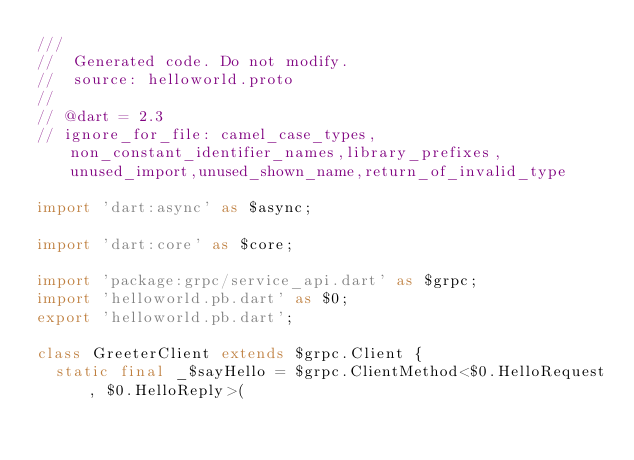Convert code to text. <code><loc_0><loc_0><loc_500><loc_500><_Dart_>///
//  Generated code. Do not modify.
//  source: helloworld.proto
//
// @dart = 2.3
// ignore_for_file: camel_case_types,non_constant_identifier_names,library_prefixes,unused_import,unused_shown_name,return_of_invalid_type

import 'dart:async' as $async;

import 'dart:core' as $core;

import 'package:grpc/service_api.dart' as $grpc;
import 'helloworld.pb.dart' as $0;
export 'helloworld.pb.dart';

class GreeterClient extends $grpc.Client {
  static final _$sayHello = $grpc.ClientMethod<$0.HelloRequest, $0.HelloReply>(</code> 